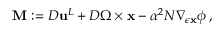Convert formula to latex. <formula><loc_0><loc_0><loc_500><loc_500>\begin{array} { r } { M \colon = { D } { u } ^ { L } + { D } \Omega \times { x } - \alpha ^ { 2 } N \nabla _ { \epsilon { x } } \phi \, , } \end{array}</formula> 